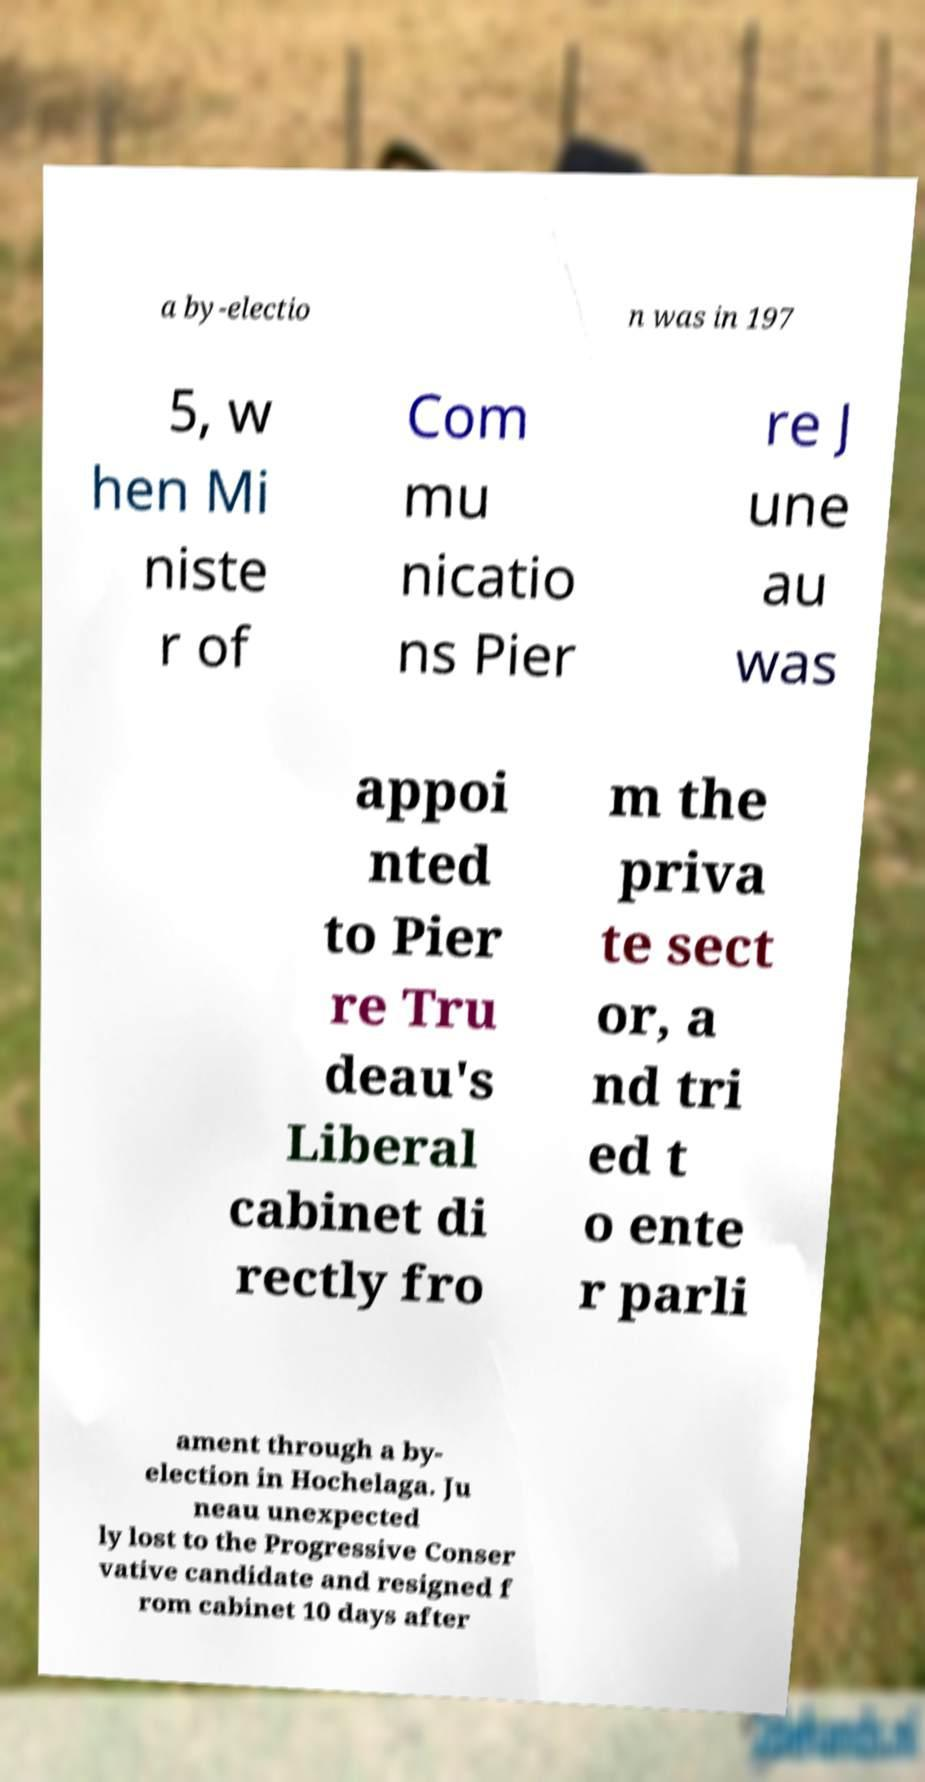I need the written content from this picture converted into text. Can you do that? a by-electio n was in 197 5, w hen Mi niste r of Com mu nicatio ns Pier re J une au was appoi nted to Pier re Tru deau's Liberal cabinet di rectly fro m the priva te sect or, a nd tri ed t o ente r parli ament through a by- election in Hochelaga. Ju neau unexpected ly lost to the Progressive Conser vative candidate and resigned f rom cabinet 10 days after 